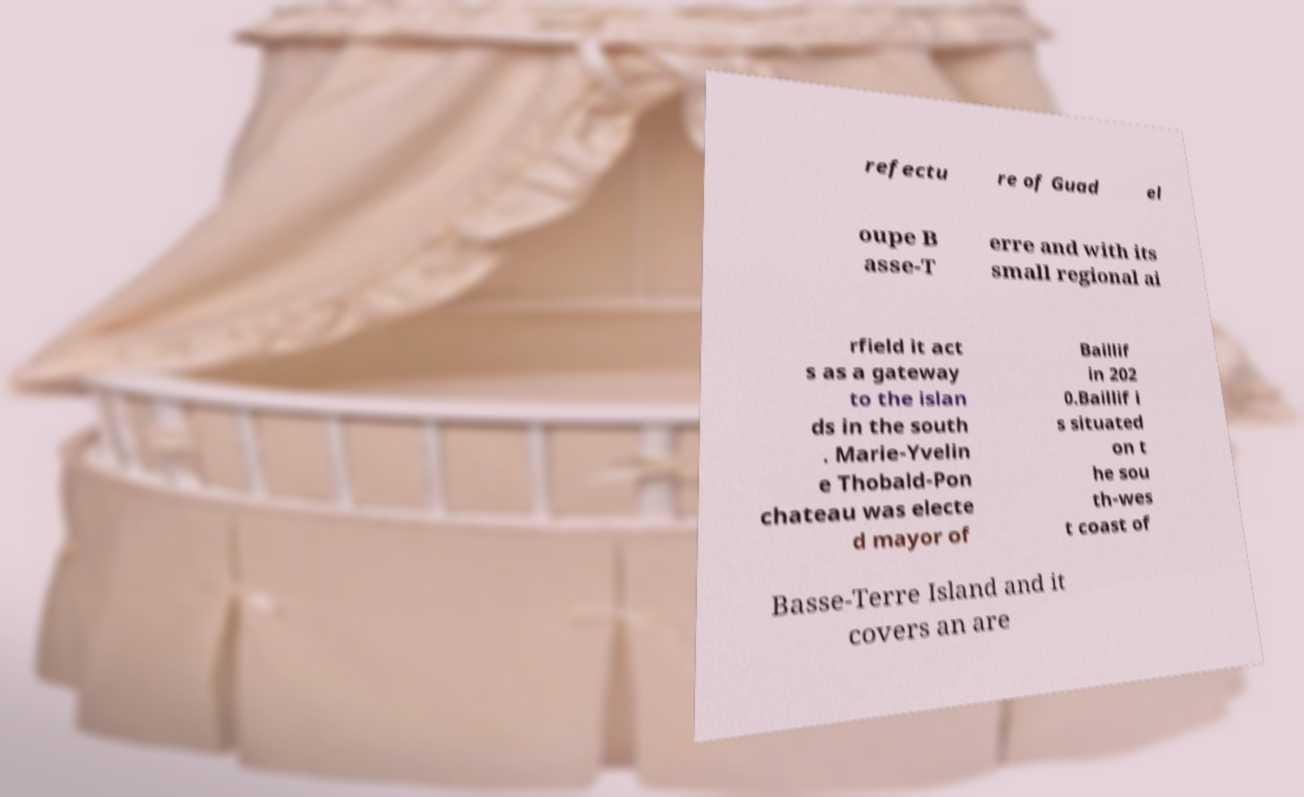I need the written content from this picture converted into text. Can you do that? refectu re of Guad el oupe B asse-T erre and with its small regional ai rfield it act s as a gateway to the islan ds in the south . Marie-Yvelin e Thobald-Pon chateau was electe d mayor of Baillif in 202 0.Baillif i s situated on t he sou th-wes t coast of Basse-Terre Island and it covers an are 